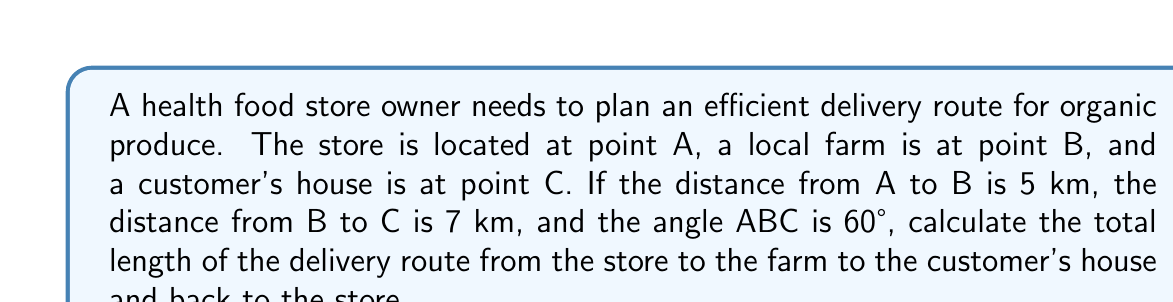What is the answer to this math problem? To solve this problem, we'll use the law of cosines and the properties of triangles. Let's break it down step-by-step:

1. First, we need to find the length of AC (the distance from the store to the customer's house) using the law of cosines:

   $$ AC^2 = AB^2 + BC^2 - 2(AB)(BC)\cos(ABC) $$

2. Substituting the known values:

   $$ AC^2 = 5^2 + 7^2 - 2(5)(7)\cos(60°) $$

3. Simplify:

   $$ AC^2 = 25 + 49 - 70\cos(60°) $$
   $$ AC^2 = 74 - 70(0.5) $$
   $$ AC^2 = 74 - 35 = 39 $$

4. Take the square root of both sides:

   $$ AC = \sqrt{39} \approx 6.245 \text{ km} $$

5. Now we have all sides of the triangle. The total delivery route length is the sum of all sides multiplied by 2 (round trip):

   $$ \text{Total route} = 2(AB + BC + AC) $$
   $$ \text{Total route} = 2(5 + 7 + 6.245) $$
   $$ \text{Total route} = 2(18.245) = 36.49 \text{ km} $$

6. Round to two decimal places:

   $$ \text{Total route} \approx 36.49 \text{ km} $$
Answer: 36.49 km 